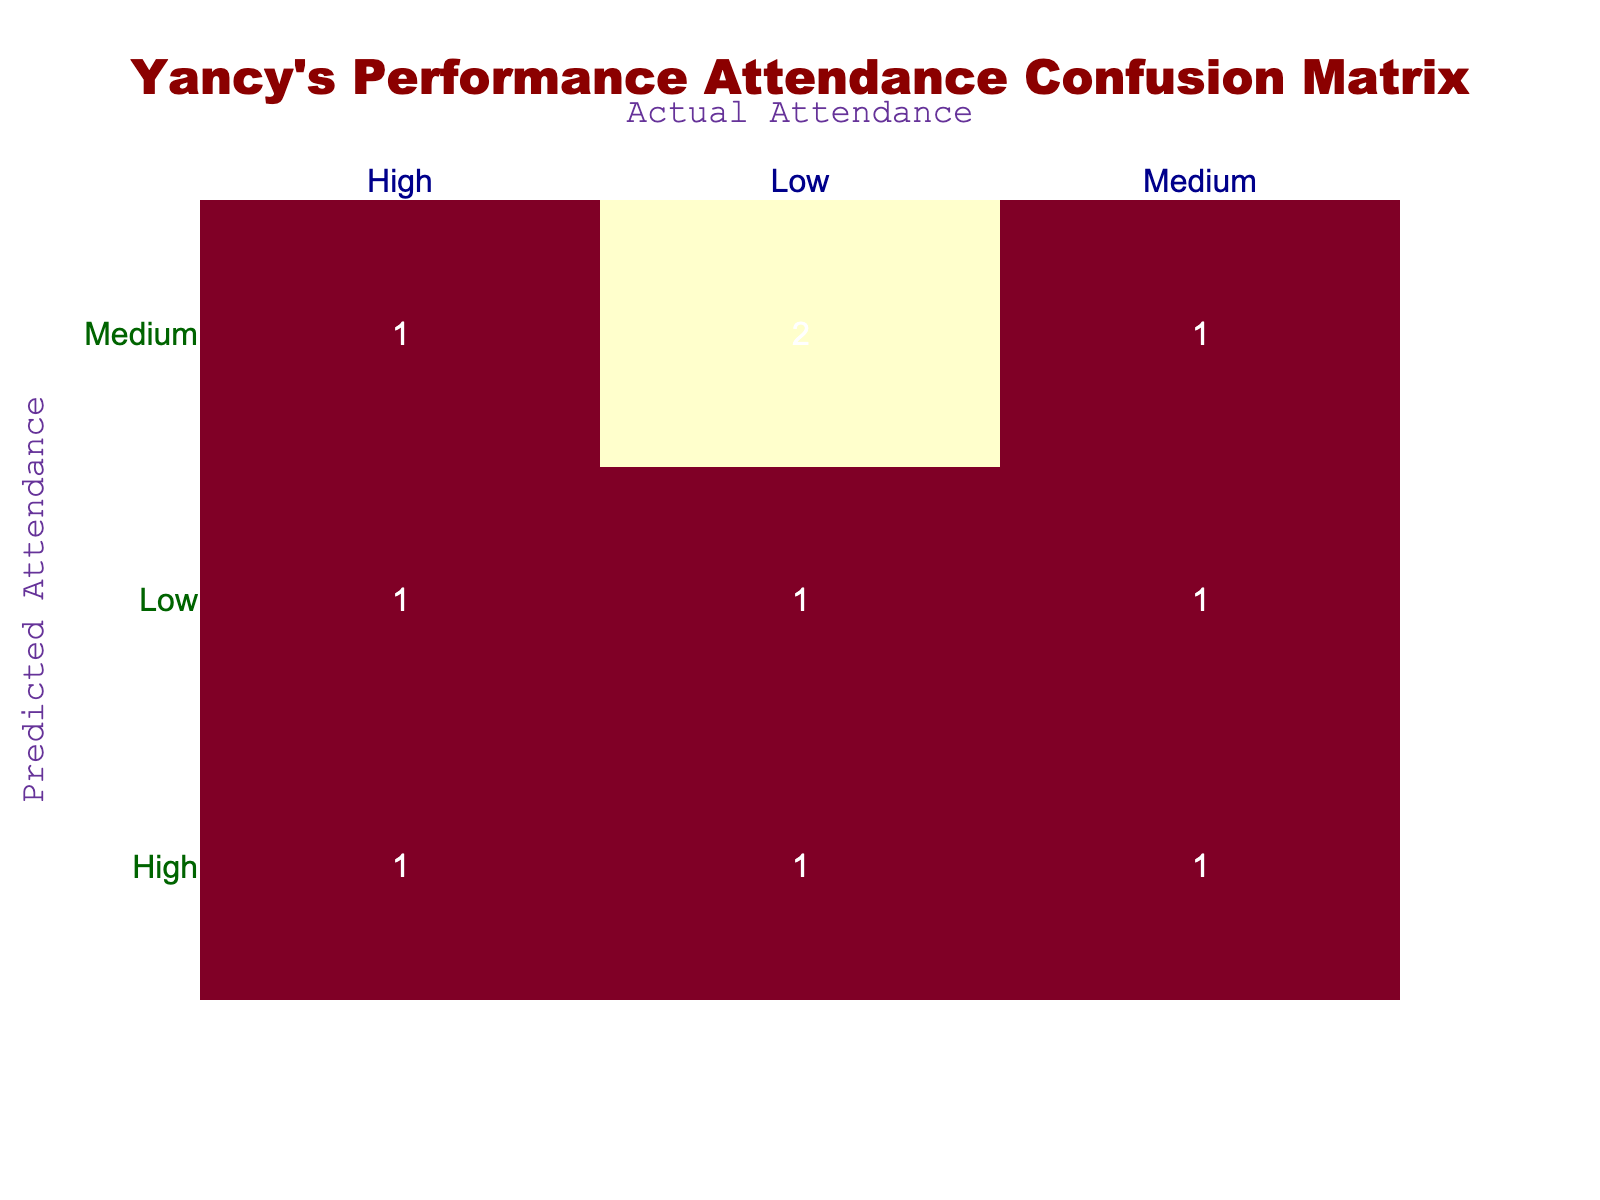What is the total number of True Positives in the confusion matrix? There are three True Positives in the table: two for the "High" category (one for High attendance, one for Medium attendance) and one for the "Medium" category (Medium attendance). Adding these up gives us a total of 3.
Answer: 3 How many instances of False Negatives are recorded for Medium predicted attendance? In the table, there are two instances where Medum predicted attendance resulted in Low actual attendance, which counts as False Negatives. Therefore, the answer is 2.
Answer: 2 Is there any instance where Low predicted attendance resulted in High actual attendance? Referring to the table, it shows that there is one instance of Low predicted attendance associated with High actual attendance, which is labeled as a False Positive. Therefore, the answer is yes.
Answer: Yes What is the sum of all instances of True Negatives and False Positives? True Negatives are represented by the one instance of Low predicted attendance with Low actual attendance, totaling 1; False Positives are instances of Low predicted attendance with High actual attendance, which also shows 1 instance. Summing these gives 1 + 1 = 2.
Answer: 2 Which predicted attendance category has the highest False Negative count? Looking at the table, the High predicted attendance category has one False Negative (High predicted and Low actual), while the Medium category has two False Negatives (both Medium predicted and Low actual). The most is in the Medium category.
Answer: Medium How many total instances are there for High predicted attendance? In the table, the High predicted attendance category appears 4 times—once each for True Positives and False Negatives, and once each for False Positives. Counting these gives a total of 4 instances.
Answer: 4 Are there more True Positives than False Positives in total? Evaluating both counts reveals that there are 3 True Positives (two in High and one in Medium) and 2 False Positives (one in Low). Thus, True Positives outnumber False Positives. Therefore, the answer is yes.
Answer: Yes What percentage of the total predictions resulted in False Negatives? The total number of predictions can be calculated by summing all instances listed in the table, which is 10. False Negatives count as 4 in total (2 High and 2 Medium). To find the percentage, we divide 4 by 10 and multiply by 100, yielding 40%.
Answer: 40% 